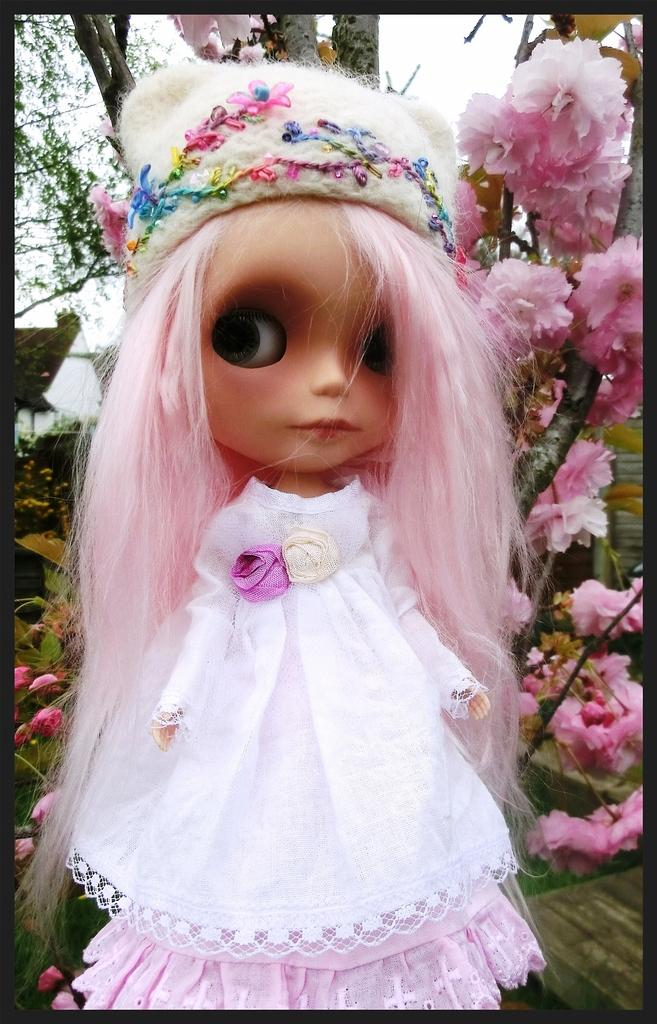What is the main subject of the image? There is a doll in the image. What is the doll wearing? The doll is wearing a white and pink dress. What can be seen in the background of the image? There are pink flowers, trees, and a house visible in the background. What does the taste of the pink flowers in the image suggest? There is no information about the taste of the pink flowers in the image, as taste cannot be determined from a visual representation. 